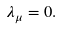<formula> <loc_0><loc_0><loc_500><loc_500>\lambda _ { \mu } = 0 .</formula> 